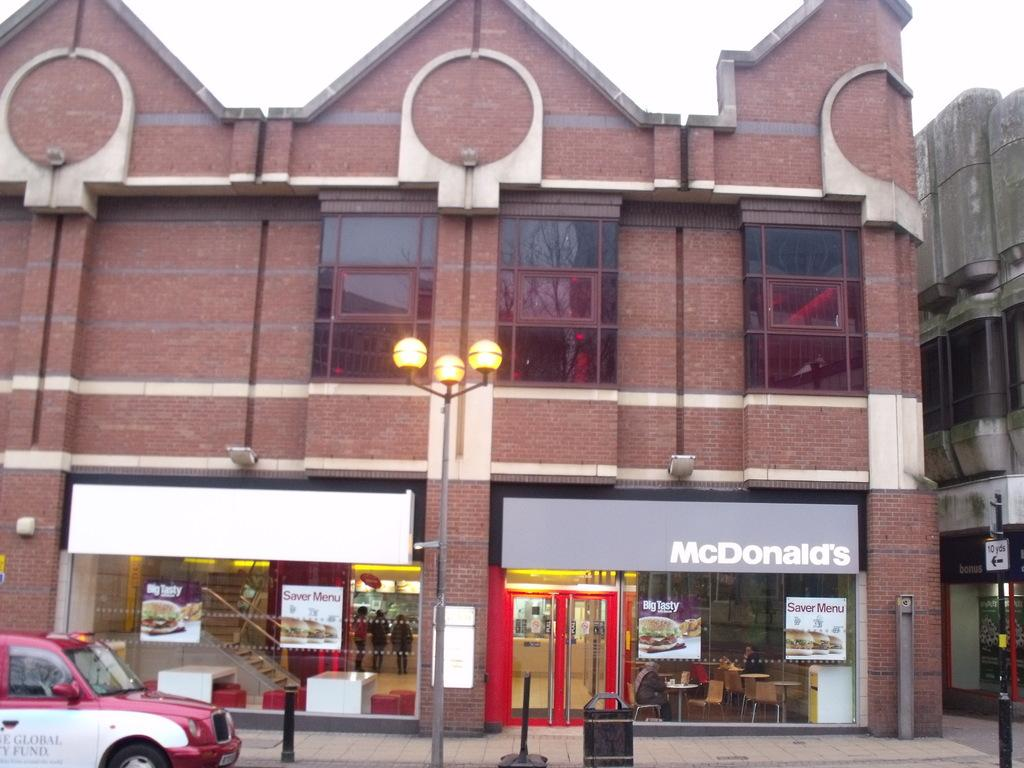<image>
Provide a brief description of the given image. A garbage can sits out in front of the mcdonalds 